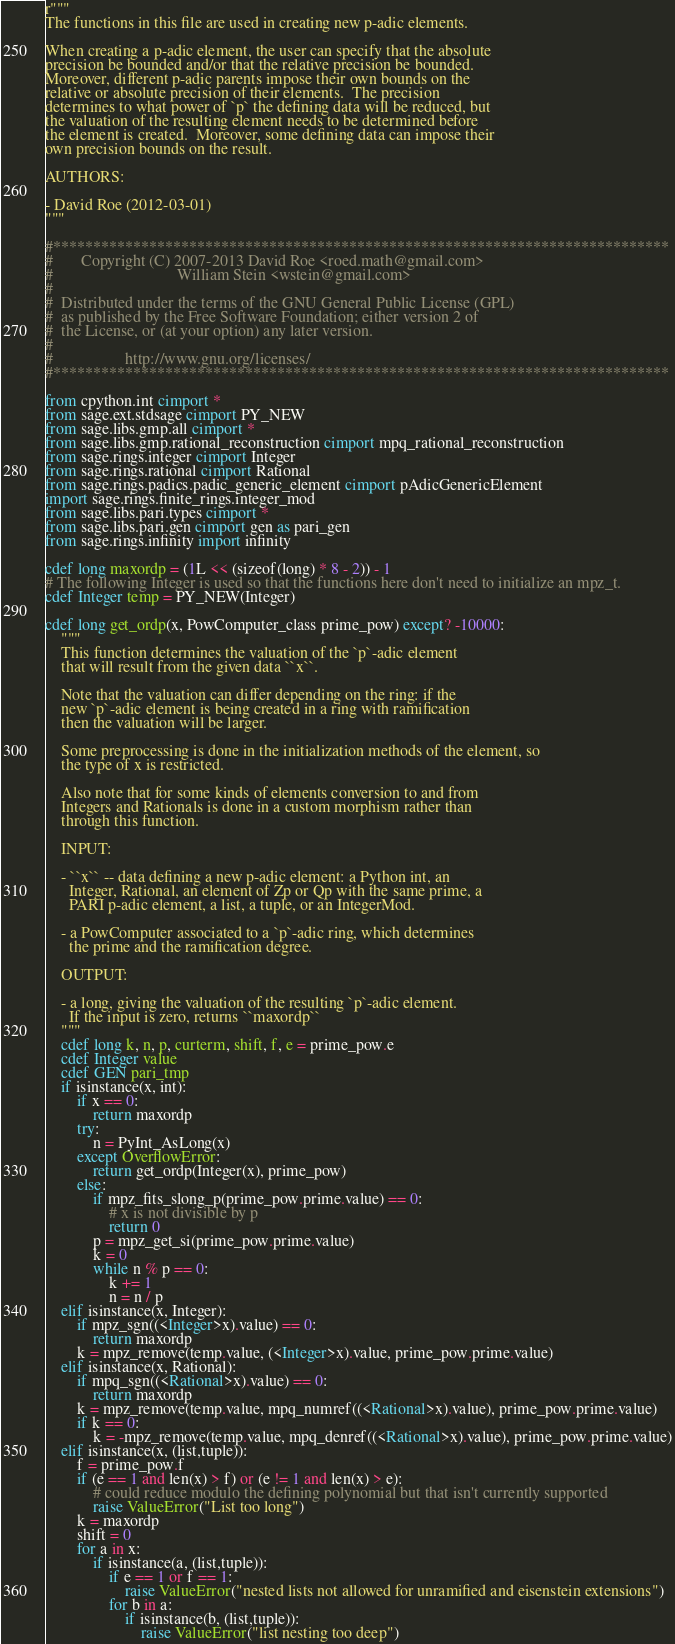Convert code to text. <code><loc_0><loc_0><loc_500><loc_500><_Cython_>r"""
The functions in this file are used in creating new p-adic elements.

When creating a p-adic element, the user can specify that the absolute
precision be bounded and/or that the relative precision be bounded.
Moreover, different p-adic parents impose their own bounds on the
relative or absolute precision of their elements.  The precision
determines to what power of `p` the defining data will be reduced, but
the valuation of the resulting element needs to be determined before
the element is created.  Moreover, some defining data can impose their
own precision bounds on the result.

AUTHORS:

- David Roe (2012-03-01)
"""

#*****************************************************************************
#       Copyright (C) 2007-2013 David Roe <roed.math@gmail.com>
#                               William Stein <wstein@gmail.com>
#
#  Distributed under the terms of the GNU General Public License (GPL)
#  as published by the Free Software Foundation; either version 2 of
#  the License, or (at your option) any later version.
#
#                  http://www.gnu.org/licenses/
#*****************************************************************************

from cpython.int cimport *
from sage.ext.stdsage cimport PY_NEW
from sage.libs.gmp.all cimport *
from sage.libs.gmp.rational_reconstruction cimport mpq_rational_reconstruction
from sage.rings.integer cimport Integer
from sage.rings.rational cimport Rational
from sage.rings.padics.padic_generic_element cimport pAdicGenericElement
import sage.rings.finite_rings.integer_mod
from sage.libs.pari.types cimport *
from sage.libs.pari.gen cimport gen as pari_gen
from sage.rings.infinity import infinity

cdef long maxordp = (1L << (sizeof(long) * 8 - 2)) - 1
# The following Integer is used so that the functions here don't need to initialize an mpz_t.
cdef Integer temp = PY_NEW(Integer)

cdef long get_ordp(x, PowComputer_class prime_pow) except? -10000:
    """
    This function determines the valuation of the `p`-adic element
    that will result from the given data ``x``.

    Note that the valuation can differ depending on the ring: if the
    new `p`-adic element is being created in a ring with ramification
    then the valuation will be larger.

    Some preprocessing is done in the initialization methods of the element, so
    the type of x is restricted.

    Also note that for some kinds of elements conversion to and from
    Integers and Rationals is done in a custom morphism rather than
    through this function.

    INPUT:

    - ``x`` -- data defining a new p-adic element: a Python int, an
      Integer, Rational, an element of Zp or Qp with the same prime, a
      PARI p-adic element, a list, a tuple, or an IntegerMod.

    - a PowComputer associated to a `p`-adic ring, which determines
      the prime and the ramification degree.

    OUTPUT:

    - a long, giving the valuation of the resulting `p`-adic element.
      If the input is zero, returns ``maxordp``
    """
    cdef long k, n, p, curterm, shift, f, e = prime_pow.e
    cdef Integer value
    cdef GEN pari_tmp
    if isinstance(x, int):
        if x == 0:
            return maxordp
        try:
            n = PyInt_AsLong(x)
        except OverflowError:
            return get_ordp(Integer(x), prime_pow)
        else:
            if mpz_fits_slong_p(prime_pow.prime.value) == 0:
                # x is not divisible by p
                return 0
            p = mpz_get_si(prime_pow.prime.value)
            k = 0
            while n % p == 0:
                k += 1
                n = n / p
    elif isinstance(x, Integer):
        if mpz_sgn((<Integer>x).value) == 0:
            return maxordp
        k = mpz_remove(temp.value, (<Integer>x).value, prime_pow.prime.value)
    elif isinstance(x, Rational):
        if mpq_sgn((<Rational>x).value) == 0:
            return maxordp
        k = mpz_remove(temp.value, mpq_numref((<Rational>x).value), prime_pow.prime.value)
        if k == 0:
            k = -mpz_remove(temp.value, mpq_denref((<Rational>x).value), prime_pow.prime.value)
    elif isinstance(x, (list,tuple)):
        f = prime_pow.f
        if (e == 1 and len(x) > f) or (e != 1 and len(x) > e):
            # could reduce modulo the defining polynomial but that isn't currently supported
            raise ValueError("List too long")
        k = maxordp
        shift = 0
        for a in x:
            if isinstance(a, (list,tuple)):
                if e == 1 or f == 1:
                    raise ValueError("nested lists not allowed for unramified and eisenstein extensions")
                for b in a:
                    if isinstance(b, (list,tuple)):
                        raise ValueError("list nesting too deep")</code> 